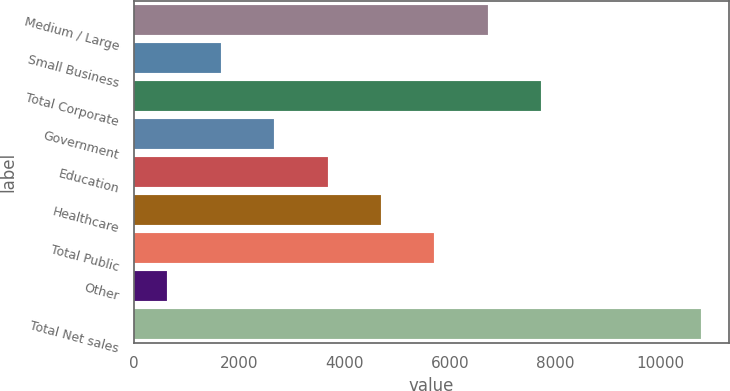<chart> <loc_0><loc_0><loc_500><loc_500><bar_chart><fcel>Medium / Large<fcel>Small Business<fcel>Total Corporate<fcel>Government<fcel>Education<fcel>Healthcare<fcel>Total Public<fcel>Other<fcel>Total Net sales<nl><fcel>6718.76<fcel>1656.46<fcel>7731.22<fcel>2668.92<fcel>3681.38<fcel>4693.84<fcel>5706.3<fcel>644<fcel>10768.6<nl></chart> 